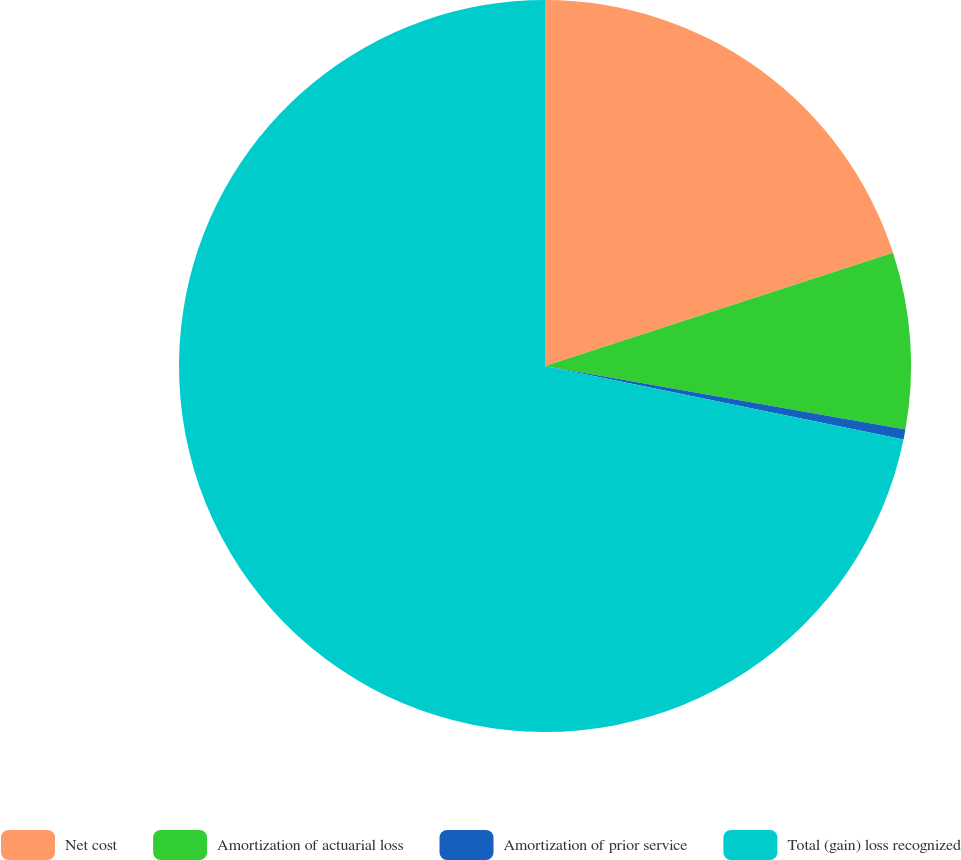Convert chart to OTSL. <chart><loc_0><loc_0><loc_500><loc_500><pie_chart><fcel>Net cost<fcel>Amortization of actuarial loss<fcel>Amortization of prior service<fcel>Total (gain) loss recognized<nl><fcel>19.99%<fcel>7.79%<fcel>0.44%<fcel>71.78%<nl></chart> 